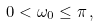<formula> <loc_0><loc_0><loc_500><loc_500>0 < \omega _ { 0 } \leq \pi \, ,</formula> 